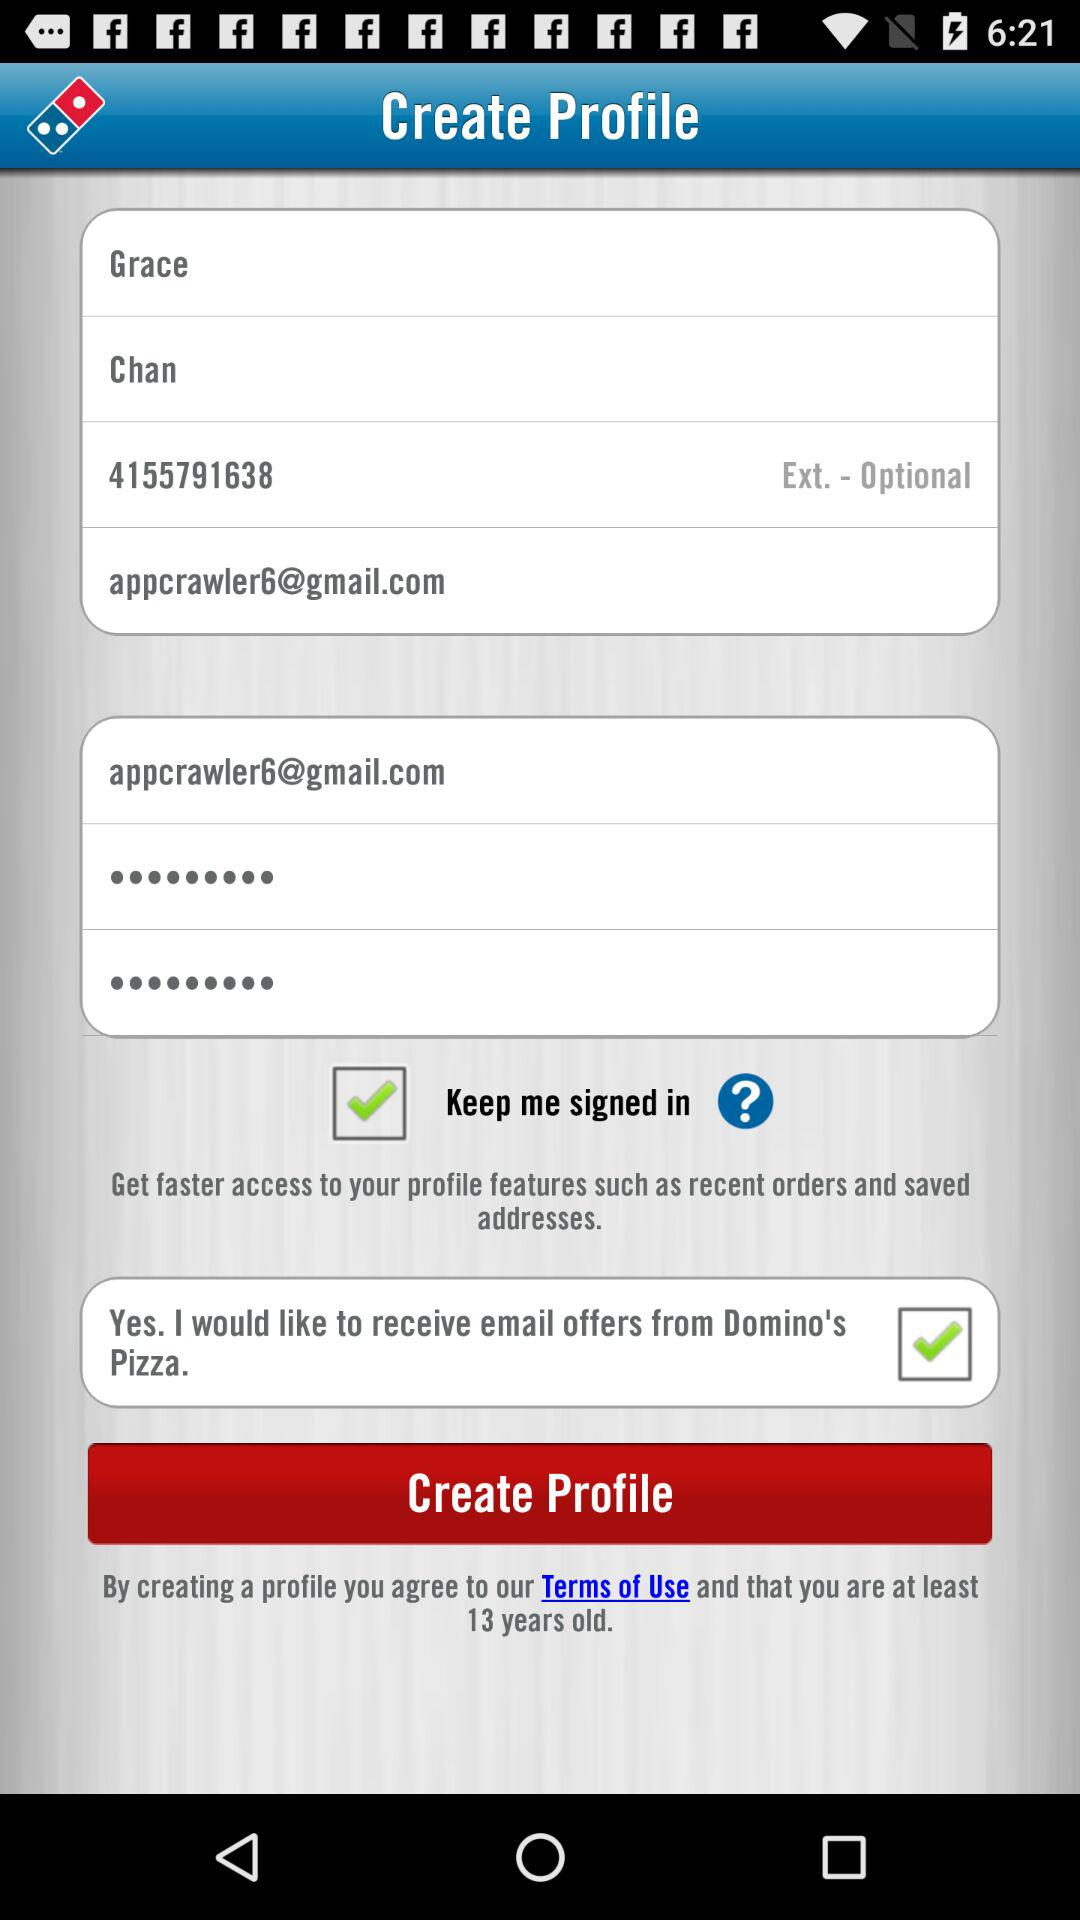What is the minimum age to create a profile? The minimum age to create a profile is 13 years. 